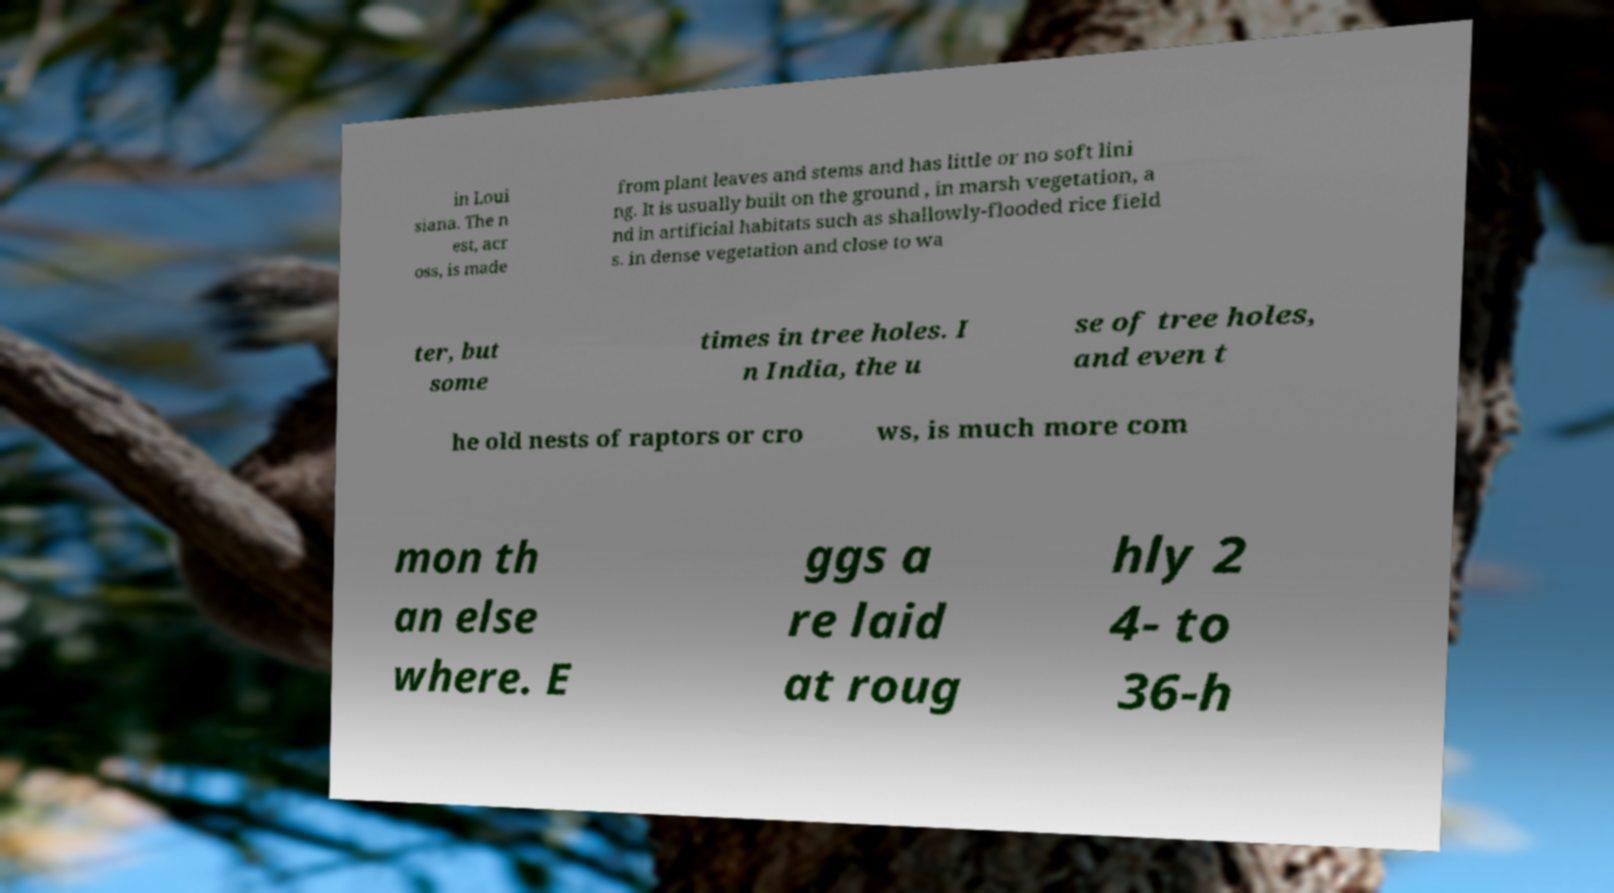I need the written content from this picture converted into text. Can you do that? in Loui siana. The n est, acr oss, is made from plant leaves and stems and has little or no soft lini ng. It is usually built on the ground , in marsh vegetation, a nd in artificial habitats such as shallowly-flooded rice field s. in dense vegetation and close to wa ter, but some times in tree holes. I n India, the u se of tree holes, and even t he old nests of raptors or cro ws, is much more com mon th an else where. E ggs a re laid at roug hly 2 4- to 36-h 